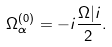<formula> <loc_0><loc_0><loc_500><loc_500>\Omega _ { \alpha } ^ { ( 0 ) } = - i \frac { \Omega | i } { 2 } .</formula> 